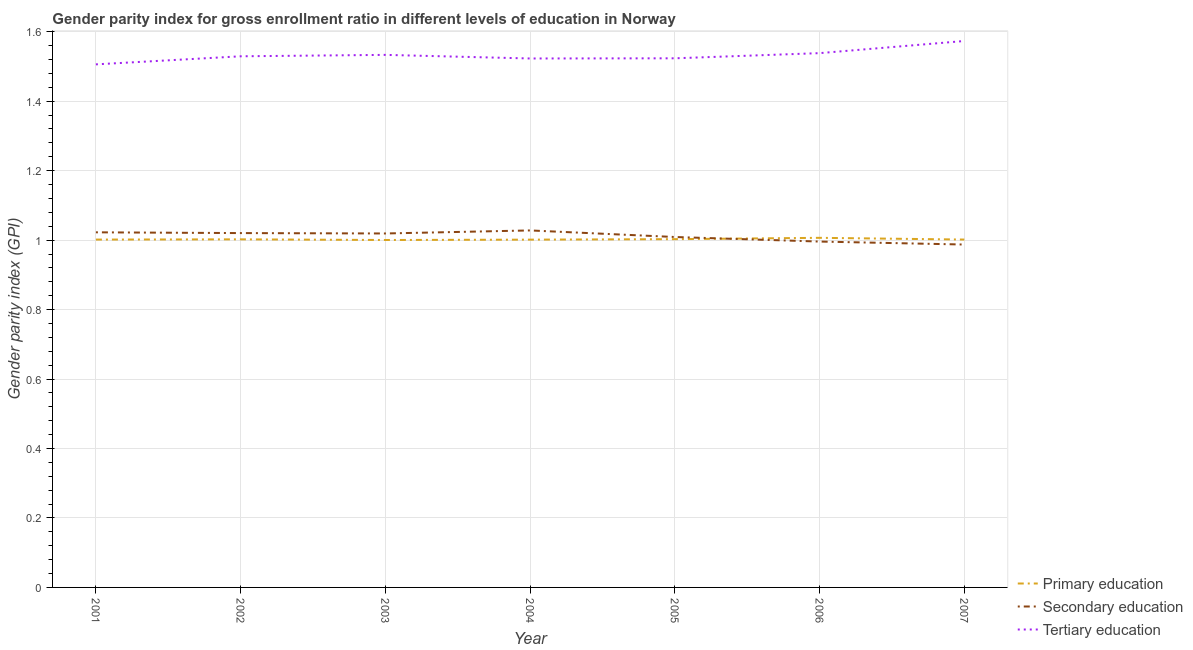Does the line corresponding to gender parity index in primary education intersect with the line corresponding to gender parity index in tertiary education?
Your answer should be compact. No. What is the gender parity index in tertiary education in 2007?
Offer a terse response. 1.57. Across all years, what is the maximum gender parity index in tertiary education?
Your response must be concise. 1.57. Across all years, what is the minimum gender parity index in tertiary education?
Offer a terse response. 1.51. In which year was the gender parity index in primary education maximum?
Provide a short and direct response. 2006. In which year was the gender parity index in tertiary education minimum?
Make the answer very short. 2001. What is the total gender parity index in primary education in the graph?
Make the answer very short. 7.02. What is the difference between the gender parity index in tertiary education in 2004 and that in 2006?
Provide a short and direct response. -0.02. What is the difference between the gender parity index in primary education in 2005 and the gender parity index in tertiary education in 2003?
Make the answer very short. -0.53. What is the average gender parity index in tertiary education per year?
Provide a succinct answer. 1.53. In the year 2005, what is the difference between the gender parity index in secondary education and gender parity index in primary education?
Give a very brief answer. 0.01. In how many years, is the gender parity index in tertiary education greater than 0.08?
Your response must be concise. 7. What is the ratio of the gender parity index in primary education in 2002 to that in 2006?
Keep it short and to the point. 1. Is the gender parity index in tertiary education in 2001 less than that in 2002?
Offer a terse response. Yes. Is the difference between the gender parity index in primary education in 2001 and 2003 greater than the difference between the gender parity index in tertiary education in 2001 and 2003?
Offer a terse response. Yes. What is the difference between the highest and the second highest gender parity index in tertiary education?
Keep it short and to the point. 0.03. What is the difference between the highest and the lowest gender parity index in tertiary education?
Provide a short and direct response. 0.07. Is it the case that in every year, the sum of the gender parity index in primary education and gender parity index in secondary education is greater than the gender parity index in tertiary education?
Make the answer very short. Yes. Is the gender parity index in secondary education strictly less than the gender parity index in tertiary education over the years?
Provide a succinct answer. Yes. How many lines are there?
Ensure brevity in your answer.  3. Are the values on the major ticks of Y-axis written in scientific E-notation?
Ensure brevity in your answer.  No. What is the title of the graph?
Offer a very short reply. Gender parity index for gross enrollment ratio in different levels of education in Norway. What is the label or title of the Y-axis?
Provide a succinct answer. Gender parity index (GPI). What is the Gender parity index (GPI) of Primary education in 2001?
Make the answer very short. 1. What is the Gender parity index (GPI) in Secondary education in 2001?
Your answer should be very brief. 1.02. What is the Gender parity index (GPI) of Tertiary education in 2001?
Make the answer very short. 1.51. What is the Gender parity index (GPI) in Primary education in 2002?
Offer a very short reply. 1. What is the Gender parity index (GPI) of Secondary education in 2002?
Make the answer very short. 1.02. What is the Gender parity index (GPI) in Tertiary education in 2002?
Provide a succinct answer. 1.53. What is the Gender parity index (GPI) of Primary education in 2003?
Your response must be concise. 1. What is the Gender parity index (GPI) of Secondary education in 2003?
Make the answer very short. 1.02. What is the Gender parity index (GPI) in Tertiary education in 2003?
Your response must be concise. 1.53. What is the Gender parity index (GPI) of Primary education in 2004?
Make the answer very short. 1. What is the Gender parity index (GPI) of Secondary education in 2004?
Offer a terse response. 1.03. What is the Gender parity index (GPI) in Tertiary education in 2004?
Ensure brevity in your answer.  1.52. What is the Gender parity index (GPI) in Primary education in 2005?
Your response must be concise. 1. What is the Gender parity index (GPI) of Secondary education in 2005?
Offer a terse response. 1.01. What is the Gender parity index (GPI) in Tertiary education in 2005?
Keep it short and to the point. 1.52. What is the Gender parity index (GPI) of Primary education in 2006?
Make the answer very short. 1.01. What is the Gender parity index (GPI) in Secondary education in 2006?
Keep it short and to the point. 1. What is the Gender parity index (GPI) in Tertiary education in 2006?
Your answer should be very brief. 1.54. What is the Gender parity index (GPI) in Primary education in 2007?
Your answer should be compact. 1. What is the Gender parity index (GPI) in Secondary education in 2007?
Your answer should be very brief. 0.99. What is the Gender parity index (GPI) of Tertiary education in 2007?
Offer a very short reply. 1.57. Across all years, what is the maximum Gender parity index (GPI) in Primary education?
Make the answer very short. 1.01. Across all years, what is the maximum Gender parity index (GPI) of Secondary education?
Make the answer very short. 1.03. Across all years, what is the maximum Gender parity index (GPI) in Tertiary education?
Your response must be concise. 1.57. Across all years, what is the minimum Gender parity index (GPI) of Primary education?
Ensure brevity in your answer.  1. Across all years, what is the minimum Gender parity index (GPI) of Secondary education?
Your answer should be very brief. 0.99. Across all years, what is the minimum Gender parity index (GPI) of Tertiary education?
Give a very brief answer. 1.51. What is the total Gender parity index (GPI) in Primary education in the graph?
Give a very brief answer. 7.02. What is the total Gender parity index (GPI) in Secondary education in the graph?
Your answer should be compact. 7.08. What is the total Gender parity index (GPI) in Tertiary education in the graph?
Offer a terse response. 10.73. What is the difference between the Gender parity index (GPI) of Primary education in 2001 and that in 2002?
Your answer should be compact. -0. What is the difference between the Gender parity index (GPI) of Secondary education in 2001 and that in 2002?
Ensure brevity in your answer.  0. What is the difference between the Gender parity index (GPI) of Tertiary education in 2001 and that in 2002?
Your answer should be compact. -0.02. What is the difference between the Gender parity index (GPI) of Primary education in 2001 and that in 2003?
Make the answer very short. 0. What is the difference between the Gender parity index (GPI) in Secondary education in 2001 and that in 2003?
Provide a short and direct response. 0. What is the difference between the Gender parity index (GPI) of Tertiary education in 2001 and that in 2003?
Make the answer very short. -0.03. What is the difference between the Gender parity index (GPI) in Primary education in 2001 and that in 2004?
Keep it short and to the point. 0. What is the difference between the Gender parity index (GPI) in Secondary education in 2001 and that in 2004?
Your answer should be compact. -0.01. What is the difference between the Gender parity index (GPI) in Tertiary education in 2001 and that in 2004?
Offer a very short reply. -0.02. What is the difference between the Gender parity index (GPI) of Primary education in 2001 and that in 2005?
Keep it short and to the point. -0. What is the difference between the Gender parity index (GPI) of Secondary education in 2001 and that in 2005?
Offer a terse response. 0.01. What is the difference between the Gender parity index (GPI) of Tertiary education in 2001 and that in 2005?
Keep it short and to the point. -0.02. What is the difference between the Gender parity index (GPI) in Primary education in 2001 and that in 2006?
Your answer should be compact. -0.01. What is the difference between the Gender parity index (GPI) in Secondary education in 2001 and that in 2006?
Provide a succinct answer. 0.03. What is the difference between the Gender parity index (GPI) in Tertiary education in 2001 and that in 2006?
Make the answer very short. -0.03. What is the difference between the Gender parity index (GPI) of Primary education in 2001 and that in 2007?
Give a very brief answer. -0. What is the difference between the Gender parity index (GPI) in Secondary education in 2001 and that in 2007?
Make the answer very short. 0.04. What is the difference between the Gender parity index (GPI) of Tertiary education in 2001 and that in 2007?
Your answer should be compact. -0.07. What is the difference between the Gender parity index (GPI) in Primary education in 2002 and that in 2003?
Your answer should be compact. 0. What is the difference between the Gender parity index (GPI) in Secondary education in 2002 and that in 2003?
Offer a very short reply. 0. What is the difference between the Gender parity index (GPI) of Tertiary education in 2002 and that in 2003?
Your answer should be compact. -0. What is the difference between the Gender parity index (GPI) in Primary education in 2002 and that in 2004?
Ensure brevity in your answer.  0. What is the difference between the Gender parity index (GPI) of Secondary education in 2002 and that in 2004?
Give a very brief answer. -0.01. What is the difference between the Gender parity index (GPI) of Tertiary education in 2002 and that in 2004?
Provide a short and direct response. 0.01. What is the difference between the Gender parity index (GPI) of Primary education in 2002 and that in 2005?
Make the answer very short. -0. What is the difference between the Gender parity index (GPI) of Secondary education in 2002 and that in 2005?
Your response must be concise. 0.01. What is the difference between the Gender parity index (GPI) in Tertiary education in 2002 and that in 2005?
Your response must be concise. 0.01. What is the difference between the Gender parity index (GPI) in Primary education in 2002 and that in 2006?
Offer a very short reply. -0. What is the difference between the Gender parity index (GPI) of Secondary education in 2002 and that in 2006?
Offer a terse response. 0.02. What is the difference between the Gender parity index (GPI) in Tertiary education in 2002 and that in 2006?
Your response must be concise. -0.01. What is the difference between the Gender parity index (GPI) in Primary education in 2002 and that in 2007?
Make the answer very short. 0. What is the difference between the Gender parity index (GPI) in Secondary education in 2002 and that in 2007?
Provide a short and direct response. 0.03. What is the difference between the Gender parity index (GPI) of Tertiary education in 2002 and that in 2007?
Ensure brevity in your answer.  -0.04. What is the difference between the Gender parity index (GPI) of Primary education in 2003 and that in 2004?
Your response must be concise. -0. What is the difference between the Gender parity index (GPI) in Secondary education in 2003 and that in 2004?
Your answer should be very brief. -0.01. What is the difference between the Gender parity index (GPI) of Tertiary education in 2003 and that in 2004?
Your response must be concise. 0.01. What is the difference between the Gender parity index (GPI) in Primary education in 2003 and that in 2005?
Provide a short and direct response. -0. What is the difference between the Gender parity index (GPI) in Secondary education in 2003 and that in 2005?
Ensure brevity in your answer.  0.01. What is the difference between the Gender parity index (GPI) in Tertiary education in 2003 and that in 2005?
Give a very brief answer. 0.01. What is the difference between the Gender parity index (GPI) in Primary education in 2003 and that in 2006?
Your answer should be compact. -0.01. What is the difference between the Gender parity index (GPI) in Secondary education in 2003 and that in 2006?
Give a very brief answer. 0.02. What is the difference between the Gender parity index (GPI) of Tertiary education in 2003 and that in 2006?
Your response must be concise. -0.01. What is the difference between the Gender parity index (GPI) of Primary education in 2003 and that in 2007?
Offer a terse response. -0. What is the difference between the Gender parity index (GPI) in Secondary education in 2003 and that in 2007?
Give a very brief answer. 0.03. What is the difference between the Gender parity index (GPI) of Tertiary education in 2003 and that in 2007?
Keep it short and to the point. -0.04. What is the difference between the Gender parity index (GPI) in Primary education in 2004 and that in 2005?
Offer a very short reply. -0. What is the difference between the Gender parity index (GPI) in Secondary education in 2004 and that in 2005?
Keep it short and to the point. 0.02. What is the difference between the Gender parity index (GPI) of Tertiary education in 2004 and that in 2005?
Offer a very short reply. -0. What is the difference between the Gender parity index (GPI) of Primary education in 2004 and that in 2006?
Provide a short and direct response. -0.01. What is the difference between the Gender parity index (GPI) of Secondary education in 2004 and that in 2006?
Keep it short and to the point. 0.03. What is the difference between the Gender parity index (GPI) of Tertiary education in 2004 and that in 2006?
Your response must be concise. -0.02. What is the difference between the Gender parity index (GPI) of Primary education in 2004 and that in 2007?
Your answer should be very brief. -0. What is the difference between the Gender parity index (GPI) in Secondary education in 2004 and that in 2007?
Make the answer very short. 0.04. What is the difference between the Gender parity index (GPI) of Tertiary education in 2004 and that in 2007?
Your response must be concise. -0.05. What is the difference between the Gender parity index (GPI) of Primary education in 2005 and that in 2006?
Keep it short and to the point. -0. What is the difference between the Gender parity index (GPI) of Secondary education in 2005 and that in 2006?
Keep it short and to the point. 0.01. What is the difference between the Gender parity index (GPI) in Tertiary education in 2005 and that in 2006?
Keep it short and to the point. -0.01. What is the difference between the Gender parity index (GPI) of Primary education in 2005 and that in 2007?
Your response must be concise. 0. What is the difference between the Gender parity index (GPI) of Secondary education in 2005 and that in 2007?
Your response must be concise. 0.02. What is the difference between the Gender parity index (GPI) in Tertiary education in 2005 and that in 2007?
Provide a succinct answer. -0.05. What is the difference between the Gender parity index (GPI) of Primary education in 2006 and that in 2007?
Provide a short and direct response. 0.01. What is the difference between the Gender parity index (GPI) in Secondary education in 2006 and that in 2007?
Make the answer very short. 0.01. What is the difference between the Gender parity index (GPI) in Tertiary education in 2006 and that in 2007?
Your answer should be very brief. -0.03. What is the difference between the Gender parity index (GPI) of Primary education in 2001 and the Gender parity index (GPI) of Secondary education in 2002?
Make the answer very short. -0.02. What is the difference between the Gender parity index (GPI) in Primary education in 2001 and the Gender parity index (GPI) in Tertiary education in 2002?
Provide a succinct answer. -0.53. What is the difference between the Gender parity index (GPI) in Secondary education in 2001 and the Gender parity index (GPI) in Tertiary education in 2002?
Ensure brevity in your answer.  -0.51. What is the difference between the Gender parity index (GPI) of Primary education in 2001 and the Gender parity index (GPI) of Secondary education in 2003?
Provide a short and direct response. -0.02. What is the difference between the Gender parity index (GPI) in Primary education in 2001 and the Gender parity index (GPI) in Tertiary education in 2003?
Offer a terse response. -0.53. What is the difference between the Gender parity index (GPI) in Secondary education in 2001 and the Gender parity index (GPI) in Tertiary education in 2003?
Ensure brevity in your answer.  -0.51. What is the difference between the Gender parity index (GPI) of Primary education in 2001 and the Gender parity index (GPI) of Secondary education in 2004?
Provide a short and direct response. -0.03. What is the difference between the Gender parity index (GPI) in Primary education in 2001 and the Gender parity index (GPI) in Tertiary education in 2004?
Offer a terse response. -0.52. What is the difference between the Gender parity index (GPI) in Secondary education in 2001 and the Gender parity index (GPI) in Tertiary education in 2004?
Ensure brevity in your answer.  -0.5. What is the difference between the Gender parity index (GPI) in Primary education in 2001 and the Gender parity index (GPI) in Secondary education in 2005?
Keep it short and to the point. -0.01. What is the difference between the Gender parity index (GPI) of Primary education in 2001 and the Gender parity index (GPI) of Tertiary education in 2005?
Offer a terse response. -0.52. What is the difference between the Gender parity index (GPI) of Secondary education in 2001 and the Gender parity index (GPI) of Tertiary education in 2005?
Your answer should be very brief. -0.5. What is the difference between the Gender parity index (GPI) of Primary education in 2001 and the Gender parity index (GPI) of Secondary education in 2006?
Ensure brevity in your answer.  0.01. What is the difference between the Gender parity index (GPI) of Primary education in 2001 and the Gender parity index (GPI) of Tertiary education in 2006?
Offer a terse response. -0.54. What is the difference between the Gender parity index (GPI) in Secondary education in 2001 and the Gender parity index (GPI) in Tertiary education in 2006?
Provide a succinct answer. -0.52. What is the difference between the Gender parity index (GPI) in Primary education in 2001 and the Gender parity index (GPI) in Secondary education in 2007?
Offer a terse response. 0.01. What is the difference between the Gender parity index (GPI) in Primary education in 2001 and the Gender parity index (GPI) in Tertiary education in 2007?
Ensure brevity in your answer.  -0.57. What is the difference between the Gender parity index (GPI) of Secondary education in 2001 and the Gender parity index (GPI) of Tertiary education in 2007?
Give a very brief answer. -0.55. What is the difference between the Gender parity index (GPI) in Primary education in 2002 and the Gender parity index (GPI) in Secondary education in 2003?
Keep it short and to the point. -0.02. What is the difference between the Gender parity index (GPI) in Primary education in 2002 and the Gender parity index (GPI) in Tertiary education in 2003?
Ensure brevity in your answer.  -0.53. What is the difference between the Gender parity index (GPI) of Secondary education in 2002 and the Gender parity index (GPI) of Tertiary education in 2003?
Your response must be concise. -0.51. What is the difference between the Gender parity index (GPI) of Primary education in 2002 and the Gender parity index (GPI) of Secondary education in 2004?
Your answer should be very brief. -0.03. What is the difference between the Gender parity index (GPI) of Primary education in 2002 and the Gender parity index (GPI) of Tertiary education in 2004?
Your answer should be very brief. -0.52. What is the difference between the Gender parity index (GPI) in Secondary education in 2002 and the Gender parity index (GPI) in Tertiary education in 2004?
Offer a terse response. -0.5. What is the difference between the Gender parity index (GPI) of Primary education in 2002 and the Gender parity index (GPI) of Secondary education in 2005?
Offer a very short reply. -0.01. What is the difference between the Gender parity index (GPI) of Primary education in 2002 and the Gender parity index (GPI) of Tertiary education in 2005?
Keep it short and to the point. -0.52. What is the difference between the Gender parity index (GPI) of Secondary education in 2002 and the Gender parity index (GPI) of Tertiary education in 2005?
Provide a short and direct response. -0.5. What is the difference between the Gender parity index (GPI) in Primary education in 2002 and the Gender parity index (GPI) in Secondary education in 2006?
Give a very brief answer. 0.01. What is the difference between the Gender parity index (GPI) of Primary education in 2002 and the Gender parity index (GPI) of Tertiary education in 2006?
Make the answer very short. -0.54. What is the difference between the Gender parity index (GPI) in Secondary education in 2002 and the Gender parity index (GPI) in Tertiary education in 2006?
Ensure brevity in your answer.  -0.52. What is the difference between the Gender parity index (GPI) of Primary education in 2002 and the Gender parity index (GPI) of Secondary education in 2007?
Your response must be concise. 0.01. What is the difference between the Gender parity index (GPI) in Primary education in 2002 and the Gender parity index (GPI) in Tertiary education in 2007?
Provide a succinct answer. -0.57. What is the difference between the Gender parity index (GPI) in Secondary education in 2002 and the Gender parity index (GPI) in Tertiary education in 2007?
Your response must be concise. -0.55. What is the difference between the Gender parity index (GPI) in Primary education in 2003 and the Gender parity index (GPI) in Secondary education in 2004?
Provide a short and direct response. -0.03. What is the difference between the Gender parity index (GPI) of Primary education in 2003 and the Gender parity index (GPI) of Tertiary education in 2004?
Offer a terse response. -0.52. What is the difference between the Gender parity index (GPI) in Secondary education in 2003 and the Gender parity index (GPI) in Tertiary education in 2004?
Offer a very short reply. -0.5. What is the difference between the Gender parity index (GPI) in Primary education in 2003 and the Gender parity index (GPI) in Secondary education in 2005?
Your answer should be very brief. -0.01. What is the difference between the Gender parity index (GPI) in Primary education in 2003 and the Gender parity index (GPI) in Tertiary education in 2005?
Your response must be concise. -0.52. What is the difference between the Gender parity index (GPI) of Secondary education in 2003 and the Gender parity index (GPI) of Tertiary education in 2005?
Your answer should be very brief. -0.5. What is the difference between the Gender parity index (GPI) of Primary education in 2003 and the Gender parity index (GPI) of Secondary education in 2006?
Your response must be concise. 0. What is the difference between the Gender parity index (GPI) in Primary education in 2003 and the Gender parity index (GPI) in Tertiary education in 2006?
Give a very brief answer. -0.54. What is the difference between the Gender parity index (GPI) of Secondary education in 2003 and the Gender parity index (GPI) of Tertiary education in 2006?
Provide a succinct answer. -0.52. What is the difference between the Gender parity index (GPI) of Primary education in 2003 and the Gender parity index (GPI) of Secondary education in 2007?
Provide a succinct answer. 0.01. What is the difference between the Gender parity index (GPI) of Primary education in 2003 and the Gender parity index (GPI) of Tertiary education in 2007?
Offer a terse response. -0.57. What is the difference between the Gender parity index (GPI) in Secondary education in 2003 and the Gender parity index (GPI) in Tertiary education in 2007?
Ensure brevity in your answer.  -0.55. What is the difference between the Gender parity index (GPI) in Primary education in 2004 and the Gender parity index (GPI) in Secondary education in 2005?
Keep it short and to the point. -0.01. What is the difference between the Gender parity index (GPI) in Primary education in 2004 and the Gender parity index (GPI) in Tertiary education in 2005?
Make the answer very short. -0.52. What is the difference between the Gender parity index (GPI) of Secondary education in 2004 and the Gender parity index (GPI) of Tertiary education in 2005?
Offer a very short reply. -0.5. What is the difference between the Gender parity index (GPI) in Primary education in 2004 and the Gender parity index (GPI) in Secondary education in 2006?
Ensure brevity in your answer.  0.01. What is the difference between the Gender parity index (GPI) in Primary education in 2004 and the Gender parity index (GPI) in Tertiary education in 2006?
Your response must be concise. -0.54. What is the difference between the Gender parity index (GPI) of Secondary education in 2004 and the Gender parity index (GPI) of Tertiary education in 2006?
Your response must be concise. -0.51. What is the difference between the Gender parity index (GPI) in Primary education in 2004 and the Gender parity index (GPI) in Secondary education in 2007?
Your answer should be compact. 0.01. What is the difference between the Gender parity index (GPI) in Primary education in 2004 and the Gender parity index (GPI) in Tertiary education in 2007?
Offer a terse response. -0.57. What is the difference between the Gender parity index (GPI) of Secondary education in 2004 and the Gender parity index (GPI) of Tertiary education in 2007?
Give a very brief answer. -0.55. What is the difference between the Gender parity index (GPI) in Primary education in 2005 and the Gender parity index (GPI) in Secondary education in 2006?
Make the answer very short. 0.01. What is the difference between the Gender parity index (GPI) in Primary education in 2005 and the Gender parity index (GPI) in Tertiary education in 2006?
Give a very brief answer. -0.54. What is the difference between the Gender parity index (GPI) in Secondary education in 2005 and the Gender parity index (GPI) in Tertiary education in 2006?
Your answer should be very brief. -0.53. What is the difference between the Gender parity index (GPI) in Primary education in 2005 and the Gender parity index (GPI) in Secondary education in 2007?
Offer a very short reply. 0.02. What is the difference between the Gender parity index (GPI) in Primary education in 2005 and the Gender parity index (GPI) in Tertiary education in 2007?
Your answer should be compact. -0.57. What is the difference between the Gender parity index (GPI) in Secondary education in 2005 and the Gender parity index (GPI) in Tertiary education in 2007?
Give a very brief answer. -0.56. What is the difference between the Gender parity index (GPI) of Primary education in 2006 and the Gender parity index (GPI) of Secondary education in 2007?
Your answer should be very brief. 0.02. What is the difference between the Gender parity index (GPI) in Primary education in 2006 and the Gender parity index (GPI) in Tertiary education in 2007?
Ensure brevity in your answer.  -0.57. What is the difference between the Gender parity index (GPI) in Secondary education in 2006 and the Gender parity index (GPI) in Tertiary education in 2007?
Your answer should be compact. -0.58. What is the average Gender parity index (GPI) in Secondary education per year?
Ensure brevity in your answer.  1.01. What is the average Gender parity index (GPI) of Tertiary education per year?
Provide a short and direct response. 1.53. In the year 2001, what is the difference between the Gender parity index (GPI) in Primary education and Gender parity index (GPI) in Secondary education?
Your answer should be very brief. -0.02. In the year 2001, what is the difference between the Gender parity index (GPI) in Primary education and Gender parity index (GPI) in Tertiary education?
Ensure brevity in your answer.  -0.5. In the year 2001, what is the difference between the Gender parity index (GPI) of Secondary education and Gender parity index (GPI) of Tertiary education?
Your answer should be very brief. -0.48. In the year 2002, what is the difference between the Gender parity index (GPI) in Primary education and Gender parity index (GPI) in Secondary education?
Make the answer very short. -0.02. In the year 2002, what is the difference between the Gender parity index (GPI) in Primary education and Gender parity index (GPI) in Tertiary education?
Provide a succinct answer. -0.53. In the year 2002, what is the difference between the Gender parity index (GPI) of Secondary education and Gender parity index (GPI) of Tertiary education?
Give a very brief answer. -0.51. In the year 2003, what is the difference between the Gender parity index (GPI) of Primary education and Gender parity index (GPI) of Secondary education?
Your answer should be compact. -0.02. In the year 2003, what is the difference between the Gender parity index (GPI) of Primary education and Gender parity index (GPI) of Tertiary education?
Provide a succinct answer. -0.53. In the year 2003, what is the difference between the Gender parity index (GPI) of Secondary education and Gender parity index (GPI) of Tertiary education?
Offer a very short reply. -0.51. In the year 2004, what is the difference between the Gender parity index (GPI) of Primary education and Gender parity index (GPI) of Secondary education?
Make the answer very short. -0.03. In the year 2004, what is the difference between the Gender parity index (GPI) of Primary education and Gender parity index (GPI) of Tertiary education?
Offer a very short reply. -0.52. In the year 2004, what is the difference between the Gender parity index (GPI) in Secondary education and Gender parity index (GPI) in Tertiary education?
Your answer should be very brief. -0.5. In the year 2005, what is the difference between the Gender parity index (GPI) of Primary education and Gender parity index (GPI) of Secondary education?
Your response must be concise. -0.01. In the year 2005, what is the difference between the Gender parity index (GPI) in Primary education and Gender parity index (GPI) in Tertiary education?
Give a very brief answer. -0.52. In the year 2005, what is the difference between the Gender parity index (GPI) in Secondary education and Gender parity index (GPI) in Tertiary education?
Your answer should be very brief. -0.51. In the year 2006, what is the difference between the Gender parity index (GPI) of Primary education and Gender parity index (GPI) of Secondary education?
Keep it short and to the point. 0.01. In the year 2006, what is the difference between the Gender parity index (GPI) of Primary education and Gender parity index (GPI) of Tertiary education?
Your answer should be compact. -0.53. In the year 2006, what is the difference between the Gender parity index (GPI) in Secondary education and Gender parity index (GPI) in Tertiary education?
Offer a very short reply. -0.54. In the year 2007, what is the difference between the Gender parity index (GPI) of Primary education and Gender parity index (GPI) of Secondary education?
Your response must be concise. 0.01. In the year 2007, what is the difference between the Gender parity index (GPI) in Primary education and Gender parity index (GPI) in Tertiary education?
Your answer should be compact. -0.57. In the year 2007, what is the difference between the Gender parity index (GPI) in Secondary education and Gender parity index (GPI) in Tertiary education?
Provide a succinct answer. -0.59. What is the ratio of the Gender parity index (GPI) of Secondary education in 2001 to that in 2002?
Make the answer very short. 1. What is the ratio of the Gender parity index (GPI) in Tertiary education in 2001 to that in 2002?
Offer a terse response. 0.98. What is the ratio of the Gender parity index (GPI) in Primary education in 2001 to that in 2003?
Your answer should be very brief. 1. What is the ratio of the Gender parity index (GPI) in Secondary education in 2001 to that in 2003?
Your answer should be compact. 1. What is the ratio of the Gender parity index (GPI) of Tertiary education in 2001 to that in 2003?
Your answer should be very brief. 0.98. What is the ratio of the Gender parity index (GPI) in Tertiary education in 2001 to that in 2004?
Offer a terse response. 0.99. What is the ratio of the Gender parity index (GPI) of Primary education in 2001 to that in 2005?
Provide a short and direct response. 1. What is the ratio of the Gender parity index (GPI) in Secondary education in 2001 to that in 2005?
Your response must be concise. 1.01. What is the ratio of the Gender parity index (GPI) in Primary education in 2001 to that in 2006?
Provide a succinct answer. 0.99. What is the ratio of the Gender parity index (GPI) in Secondary education in 2001 to that in 2006?
Your response must be concise. 1.03. What is the ratio of the Gender parity index (GPI) of Tertiary education in 2001 to that in 2006?
Offer a very short reply. 0.98. What is the ratio of the Gender parity index (GPI) of Primary education in 2001 to that in 2007?
Provide a short and direct response. 1. What is the ratio of the Gender parity index (GPI) in Secondary education in 2001 to that in 2007?
Your response must be concise. 1.04. What is the ratio of the Gender parity index (GPI) in Tertiary education in 2001 to that in 2007?
Provide a short and direct response. 0.96. What is the ratio of the Gender parity index (GPI) of Secondary education in 2002 to that in 2003?
Make the answer very short. 1. What is the ratio of the Gender parity index (GPI) of Tertiary education in 2002 to that in 2003?
Your answer should be very brief. 1. What is the ratio of the Gender parity index (GPI) of Tertiary education in 2002 to that in 2004?
Ensure brevity in your answer.  1. What is the ratio of the Gender parity index (GPI) in Secondary education in 2002 to that in 2005?
Offer a terse response. 1.01. What is the ratio of the Gender parity index (GPI) of Tertiary education in 2002 to that in 2005?
Offer a terse response. 1. What is the ratio of the Gender parity index (GPI) in Secondary education in 2002 to that in 2006?
Offer a terse response. 1.02. What is the ratio of the Gender parity index (GPI) in Primary education in 2002 to that in 2007?
Your response must be concise. 1. What is the ratio of the Gender parity index (GPI) of Secondary education in 2002 to that in 2007?
Your answer should be compact. 1.03. What is the ratio of the Gender parity index (GPI) in Tertiary education in 2002 to that in 2007?
Ensure brevity in your answer.  0.97. What is the ratio of the Gender parity index (GPI) in Primary education in 2003 to that in 2004?
Make the answer very short. 1. What is the ratio of the Gender parity index (GPI) in Tertiary education in 2003 to that in 2004?
Your answer should be compact. 1.01. What is the ratio of the Gender parity index (GPI) in Tertiary education in 2003 to that in 2005?
Ensure brevity in your answer.  1.01. What is the ratio of the Gender parity index (GPI) of Primary education in 2003 to that in 2006?
Your response must be concise. 0.99. What is the ratio of the Gender parity index (GPI) of Secondary education in 2003 to that in 2006?
Make the answer very short. 1.02. What is the ratio of the Gender parity index (GPI) in Tertiary education in 2003 to that in 2006?
Ensure brevity in your answer.  1. What is the ratio of the Gender parity index (GPI) in Secondary education in 2003 to that in 2007?
Provide a succinct answer. 1.03. What is the ratio of the Gender parity index (GPI) in Tertiary education in 2003 to that in 2007?
Ensure brevity in your answer.  0.97. What is the ratio of the Gender parity index (GPI) of Primary education in 2004 to that in 2005?
Keep it short and to the point. 1. What is the ratio of the Gender parity index (GPI) of Secondary education in 2004 to that in 2005?
Make the answer very short. 1.02. What is the ratio of the Gender parity index (GPI) in Tertiary education in 2004 to that in 2005?
Your response must be concise. 1. What is the ratio of the Gender parity index (GPI) of Primary education in 2004 to that in 2006?
Your answer should be compact. 0.99. What is the ratio of the Gender parity index (GPI) in Secondary education in 2004 to that in 2006?
Provide a succinct answer. 1.03. What is the ratio of the Gender parity index (GPI) in Secondary education in 2004 to that in 2007?
Your answer should be compact. 1.04. What is the ratio of the Gender parity index (GPI) of Tertiary education in 2004 to that in 2007?
Provide a succinct answer. 0.97. What is the ratio of the Gender parity index (GPI) of Primary education in 2005 to that in 2006?
Make the answer very short. 1. What is the ratio of the Gender parity index (GPI) in Secondary education in 2005 to that in 2006?
Make the answer very short. 1.01. What is the ratio of the Gender parity index (GPI) of Tertiary education in 2005 to that in 2006?
Provide a succinct answer. 0.99. What is the ratio of the Gender parity index (GPI) of Primary education in 2005 to that in 2007?
Provide a short and direct response. 1. What is the ratio of the Gender parity index (GPI) of Secondary education in 2005 to that in 2007?
Your answer should be very brief. 1.02. What is the ratio of the Gender parity index (GPI) of Tertiary education in 2005 to that in 2007?
Your answer should be very brief. 0.97. What is the ratio of the Gender parity index (GPI) in Secondary education in 2006 to that in 2007?
Give a very brief answer. 1.01. What is the ratio of the Gender parity index (GPI) in Tertiary education in 2006 to that in 2007?
Your answer should be very brief. 0.98. What is the difference between the highest and the second highest Gender parity index (GPI) in Primary education?
Give a very brief answer. 0. What is the difference between the highest and the second highest Gender parity index (GPI) in Secondary education?
Your answer should be very brief. 0.01. What is the difference between the highest and the second highest Gender parity index (GPI) of Tertiary education?
Your response must be concise. 0.03. What is the difference between the highest and the lowest Gender parity index (GPI) in Primary education?
Offer a terse response. 0.01. What is the difference between the highest and the lowest Gender parity index (GPI) in Secondary education?
Make the answer very short. 0.04. What is the difference between the highest and the lowest Gender parity index (GPI) in Tertiary education?
Give a very brief answer. 0.07. 